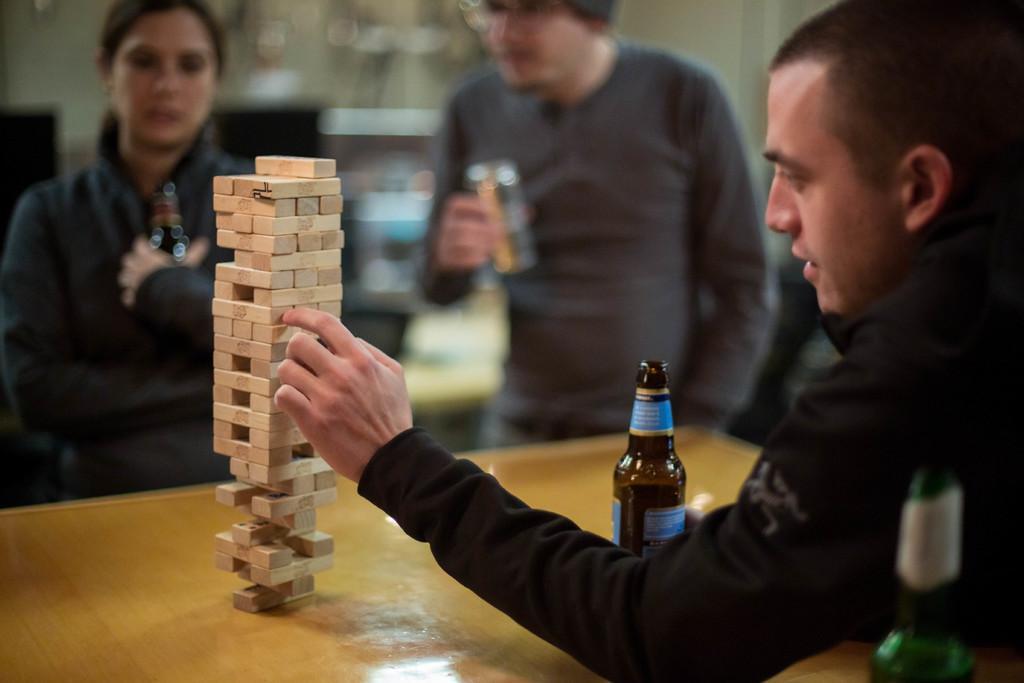How would you summarize this image in a sentence or two? There is a person on the right side and he is playing with small wooden blocks. This is a wooden table where these small wooden blocks and a wine bottle are kept on it. Here we can see two persons who are standing. 